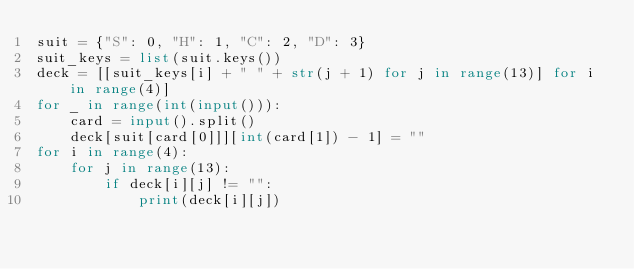Convert code to text. <code><loc_0><loc_0><loc_500><loc_500><_Python_>suit = {"S": 0, "H": 1, "C": 2, "D": 3}
suit_keys = list(suit.keys())
deck = [[suit_keys[i] + " " + str(j + 1) for j in range(13)] for i in range(4)]
for _ in range(int(input())):
    card = input().split()
    deck[suit[card[0]]][int(card[1]) - 1] = ""
for i in range(4):
    for j in range(13):
        if deck[i][j] != "":
            print(deck[i][j])

</code> 